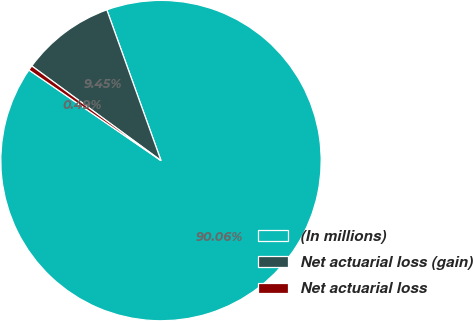Convert chart to OTSL. <chart><loc_0><loc_0><loc_500><loc_500><pie_chart><fcel>(In millions)<fcel>Net actuarial loss (gain)<fcel>Net actuarial loss<nl><fcel>90.06%<fcel>9.45%<fcel>0.49%<nl></chart> 